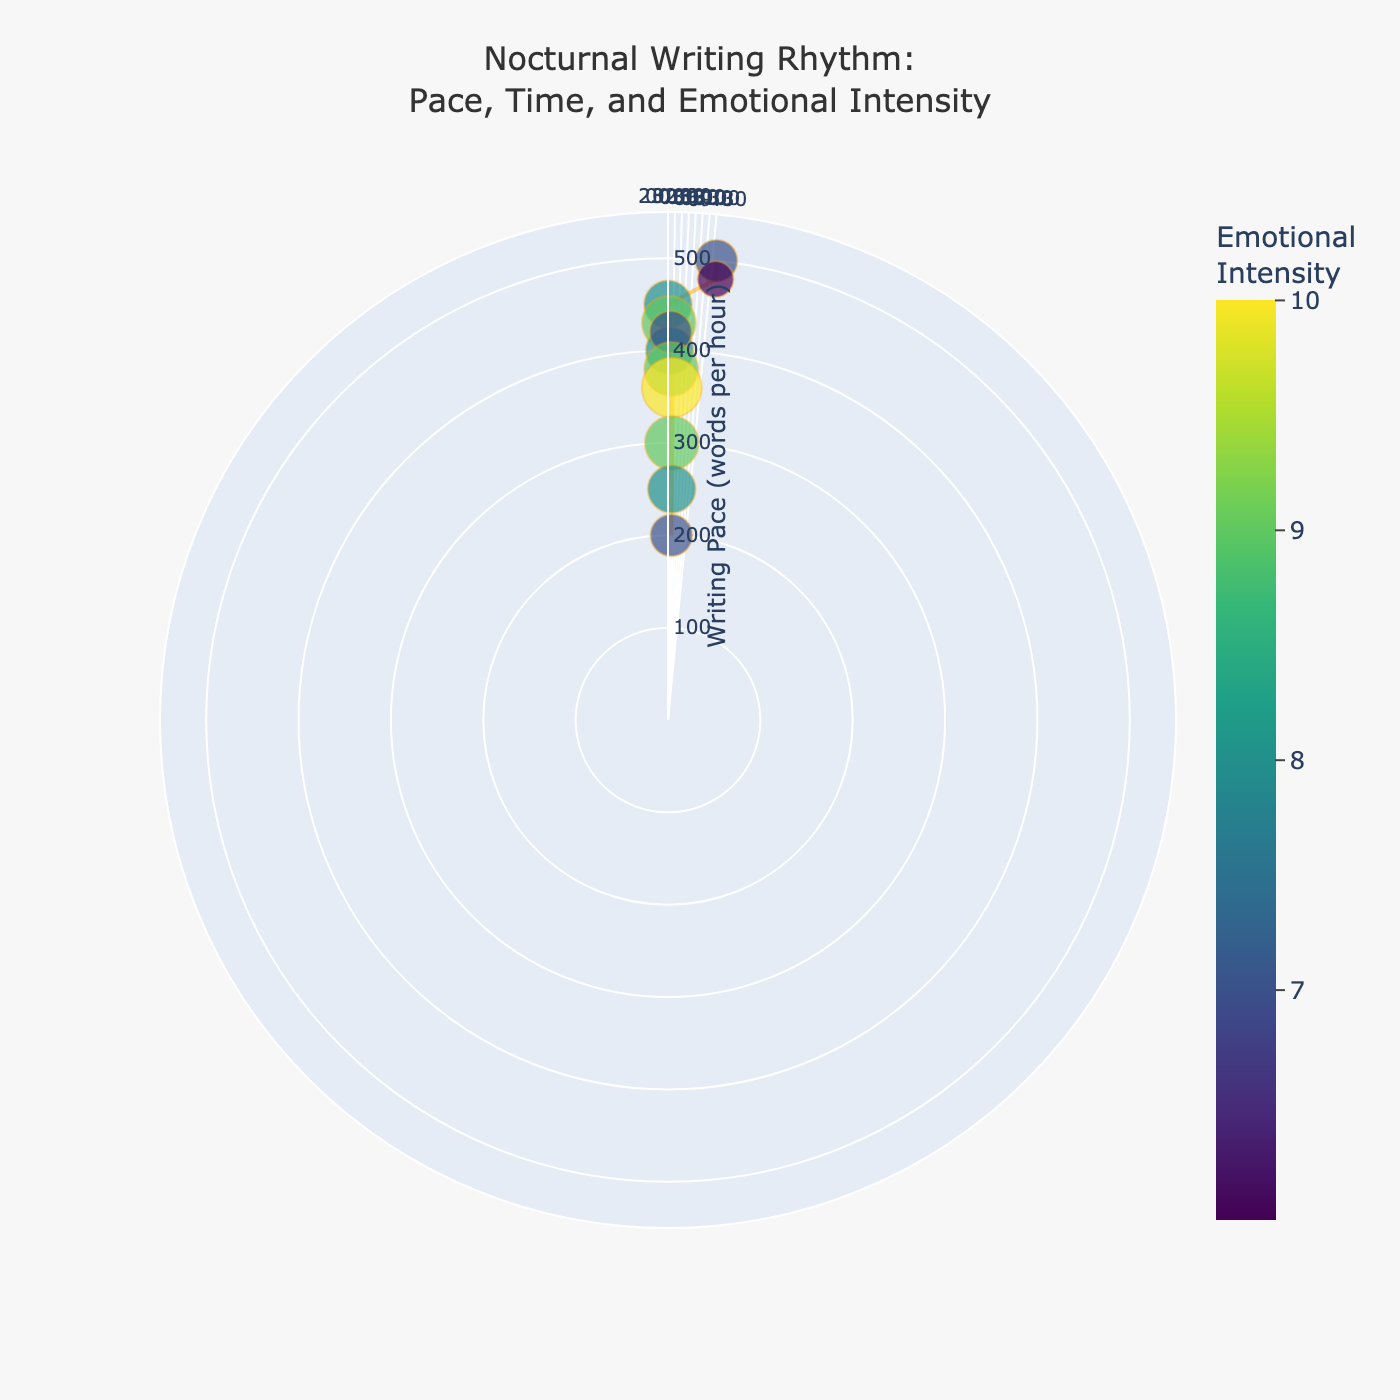What is the title of the figure? The title is prominently displayed at the top center of the figure. The text is "Nocturnal Writing Rhythm: Pace, Time, and Emotional Intensity".
Answer: Nocturnal Writing Rhythm: Pace, Time, and Emotional Intensity How many data points are there in the figure? You can count the markers plotted on the polar chart. There are a total of 11 data points shown.
Answer: 11 At which time does the writing pace drop below 400 words per hour? Locate the points where the radial distance (writing pace) is less than 400. The radial axis values for these points can be seen at times between 01:00 and 04:00.
Answer: 01:00 What is the highest writing pace recorded? The highest radial distance represents the highest writing pace, which is at 23:00, with a value of 500 words per hour.
Answer: 500 words per hour Which time period shows the highest emotional intensity? The largest marker size indicates the highest emotional intensity. The marker is the largest at 02:30 with an emotional intensity of 10.
Answer: 02:30 Between 00:00 and 02:30, how does the writing pace change? Examine the radial distances from 00:00 to 02:30. The writing pace decreases from 450 words per hour to 360 words per hour in this interval.
Answer: Decreases Which time has both a high writing pace and high emotional intensity? Look for high radial positions along with larger marker sizes. The 00:00 marker shows 450 words per hour and an emotional intensity of 8.
Answer: 00:00 Compare the emotional intensity at 23:30 and 03:00. Which is higher? Compare the marker size and color at these two points. The emotional intensity at 03:00 is higher, marked by a larger size and darker shade.
Answer: 03:00 What is the writing pace at 04:00 and how does it compare to the pace at 23:00? Read the radial distance at 04:00, which is 200 words per hour, and compare it to the 500 words per hour at 23:00.
Answer: 04:00 is 300 words per hour slower What general trend can be observed in writing pace and emotional intensity over the time period shown? Observe the overall pattern of data points. Writing pace generally decreases over time, while emotional intensity tends to increase initially and then varies around high levels.
Answer: Pace decreases, intensity increases and then varies 